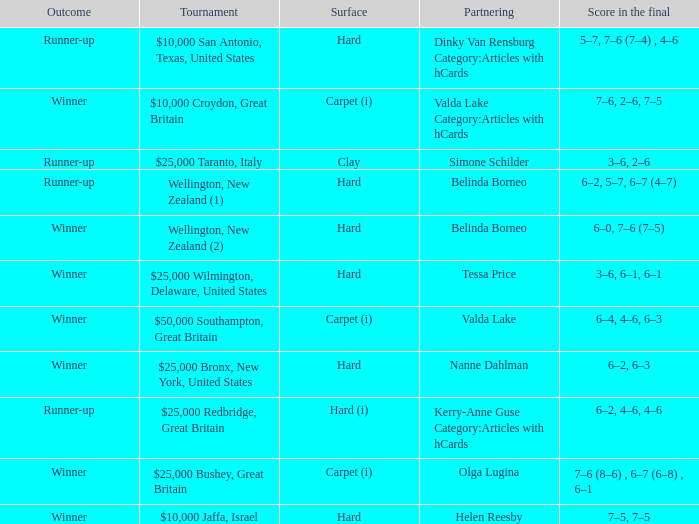What was the final score for the match with a partnering of Tessa Price? 3–6, 6–1, 6–1. 